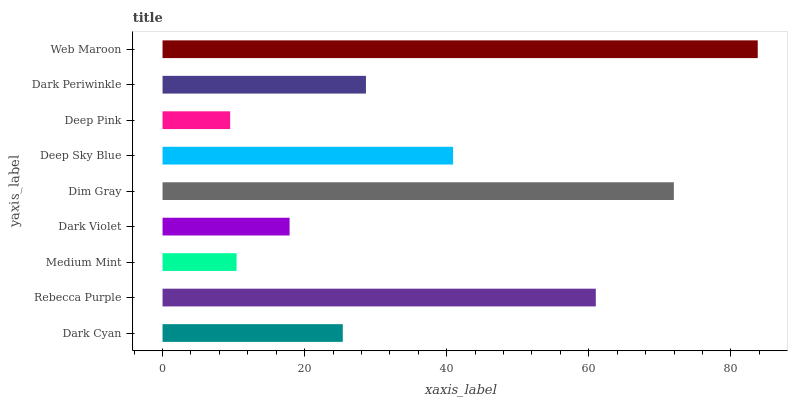Is Deep Pink the minimum?
Answer yes or no. Yes. Is Web Maroon the maximum?
Answer yes or no. Yes. Is Rebecca Purple the minimum?
Answer yes or no. No. Is Rebecca Purple the maximum?
Answer yes or no. No. Is Rebecca Purple greater than Dark Cyan?
Answer yes or no. Yes. Is Dark Cyan less than Rebecca Purple?
Answer yes or no. Yes. Is Dark Cyan greater than Rebecca Purple?
Answer yes or no. No. Is Rebecca Purple less than Dark Cyan?
Answer yes or no. No. Is Dark Periwinkle the high median?
Answer yes or no. Yes. Is Dark Periwinkle the low median?
Answer yes or no. Yes. Is Rebecca Purple the high median?
Answer yes or no. No. Is Dark Violet the low median?
Answer yes or no. No. 